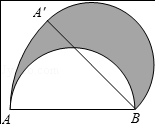What other geometric properties can be calculated based on this rotated semicircle configuration? Besides the area of the shaded sector, you can calculate the arc length of the sector, which is critical in understanding the perimeter of the figure. The formula for arc length is Theta/360 * 2 * pi * r. Given a 45 degree rotation, the arc length would hence be 45/360 * 2 * pi * 4 = pi units. 